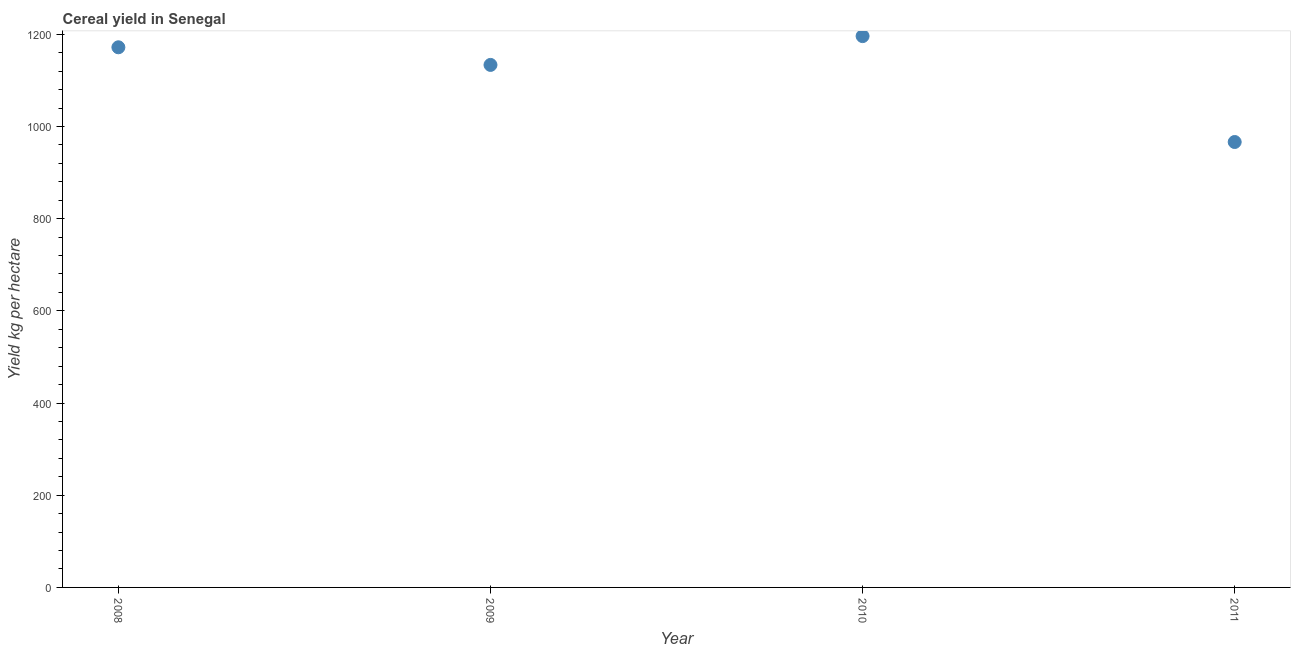What is the cereal yield in 2008?
Give a very brief answer. 1171.85. Across all years, what is the maximum cereal yield?
Offer a terse response. 1196.08. Across all years, what is the minimum cereal yield?
Make the answer very short. 966.35. What is the sum of the cereal yield?
Provide a short and direct response. 4467.89. What is the difference between the cereal yield in 2009 and 2010?
Make the answer very short. -62.47. What is the average cereal yield per year?
Provide a succinct answer. 1116.97. What is the median cereal yield?
Ensure brevity in your answer.  1152.73. In how many years, is the cereal yield greater than 320 kg per hectare?
Ensure brevity in your answer.  4. What is the ratio of the cereal yield in 2009 to that in 2011?
Provide a short and direct response. 1.17. Is the cereal yield in 2008 less than that in 2010?
Your response must be concise. Yes. What is the difference between the highest and the second highest cereal yield?
Keep it short and to the point. 24.23. What is the difference between the highest and the lowest cereal yield?
Your response must be concise. 229.73. Does the cereal yield monotonically increase over the years?
Give a very brief answer. No. How many years are there in the graph?
Keep it short and to the point. 4. Does the graph contain any zero values?
Your response must be concise. No. What is the title of the graph?
Keep it short and to the point. Cereal yield in Senegal. What is the label or title of the Y-axis?
Offer a very short reply. Yield kg per hectare. What is the Yield kg per hectare in 2008?
Your answer should be compact. 1171.85. What is the Yield kg per hectare in 2009?
Keep it short and to the point. 1133.61. What is the Yield kg per hectare in 2010?
Offer a very short reply. 1196.08. What is the Yield kg per hectare in 2011?
Offer a very short reply. 966.35. What is the difference between the Yield kg per hectare in 2008 and 2009?
Your answer should be very brief. 38.24. What is the difference between the Yield kg per hectare in 2008 and 2010?
Make the answer very short. -24.23. What is the difference between the Yield kg per hectare in 2008 and 2011?
Keep it short and to the point. 205.5. What is the difference between the Yield kg per hectare in 2009 and 2010?
Your answer should be very brief. -62.47. What is the difference between the Yield kg per hectare in 2009 and 2011?
Your answer should be very brief. 167.26. What is the difference between the Yield kg per hectare in 2010 and 2011?
Provide a short and direct response. 229.73. What is the ratio of the Yield kg per hectare in 2008 to that in 2009?
Keep it short and to the point. 1.03. What is the ratio of the Yield kg per hectare in 2008 to that in 2011?
Offer a terse response. 1.21. What is the ratio of the Yield kg per hectare in 2009 to that in 2010?
Your response must be concise. 0.95. What is the ratio of the Yield kg per hectare in 2009 to that in 2011?
Give a very brief answer. 1.17. What is the ratio of the Yield kg per hectare in 2010 to that in 2011?
Provide a succinct answer. 1.24. 